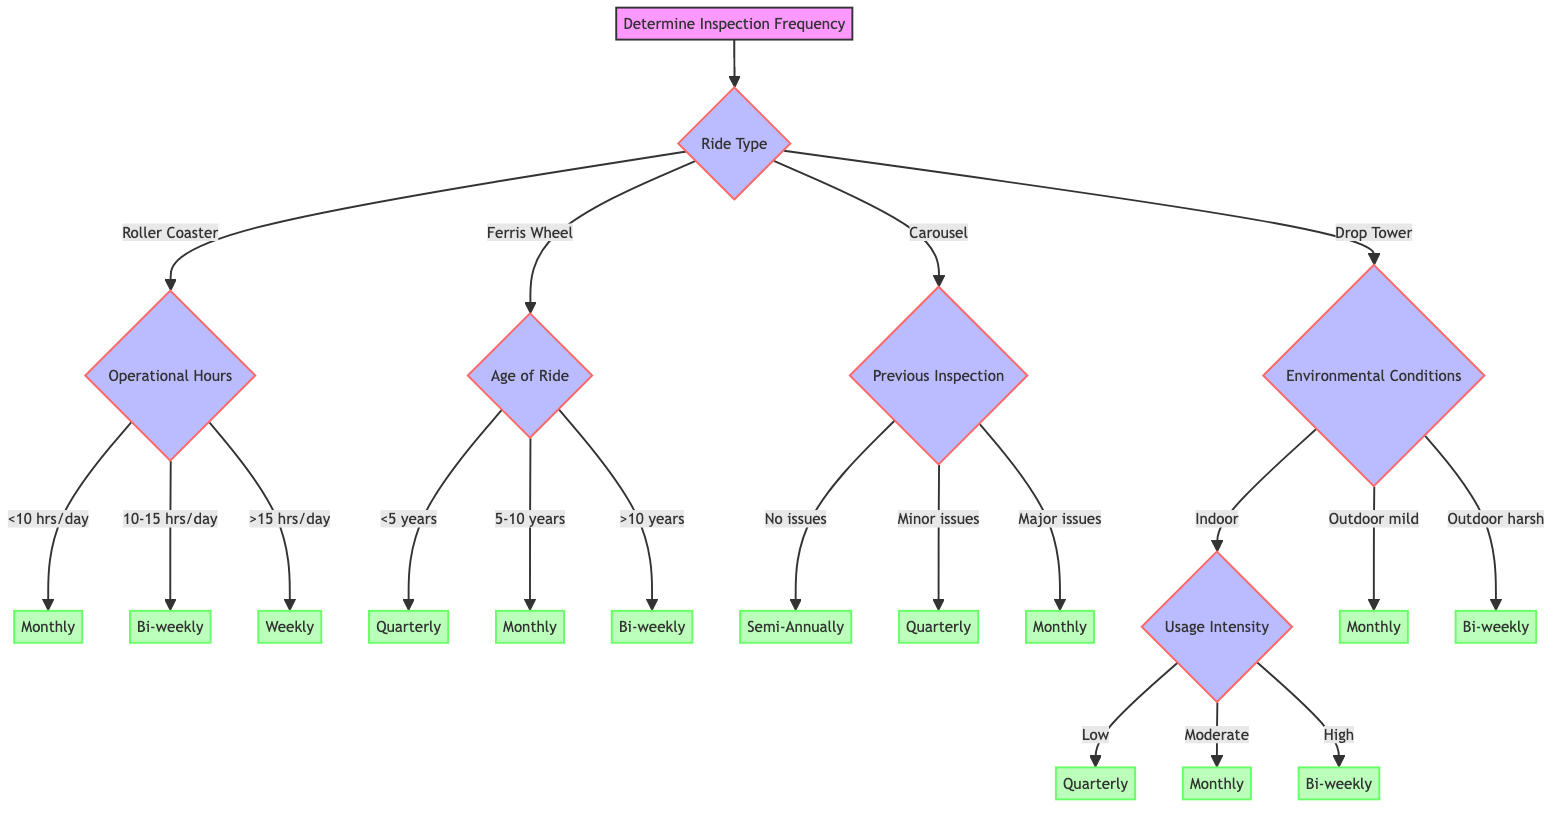What factors determine the inspection frequency? The diagram shows that inspection frequency is determined by several factors: Ride Type, Operational Hours, Age of Ride, Previous Inspection Results, Environmental Conditions, Manufacturer Recommendations, and Usage Intensity.
Answer: Ride Type, Operational Hours, Age of Ride, Previous Inspection Results, Environmental Conditions, Manufacturer Recommendations, Usage Intensity How many different ride types are considered? The diagram lists four different ride types: Roller Coaster, Ferris Wheel, Carousel, and Drop Tower. Counting these gives a total of four ride types.
Answer: 4 What is the inspection frequency for a Roller Coaster with over 15 operational hours per day? Following the path for a Roller Coaster, and then checking for Operational Hours greater than 15 hours/day leads to the inspection frequency of Weekly.
Answer: Weekly If the ride is a Ferris Wheel that is 5-10 years old, what would the inspection frequency be? Starting with the Ferris Wheel category leads to checking Age of Ride. Since it is 5-10 years old, the next decision indicates that the inspection frequency is Monthly.
Answer: Monthly What is the outcome for a Drop Tower that operates in harsh outdoor weather? From Drop Tower, the flow leads to Environmental Conditions. For Outdoor with harsh weather, the next step leads to a choice of Bi-weekly for inspection frequency.
Answer: Bi-weekly What should be the inspection frequency if the previous results showed major issues? The diagram indicates that if Previous Inspection Results show Major issues detected, the frequency should be Monthly, regardless of other factors.
Answer: Monthly How does Usage Intensity affect inspections for Indoor rides? For Indoor rides, the next decision point checks Usage Intensity, which has three levels: Low, Moderate, and High. This will determine the frequency accordingly as Quarterly, Monthly, or Bi-weekly.
Answer: Quarterly, Monthly, Bi-weekly What happens if the ride has minor issues in the previous inspection? With minor issues detected in previous inspections, the frequency for inspection is determined to be Quarterly in all cases where previous results are factored in.
Answer: Quarterly What would be the inspection frequency for a ride with less than 5 years of age and operating less than 10 hours per day? Starting from the Age of Ride of less than 5 years leads to Quarterly, and since it has less than 10 operational hours, this also matches with Monthly. However, since age determines that, the answer is Quarterly.
Answer: Quarterly 